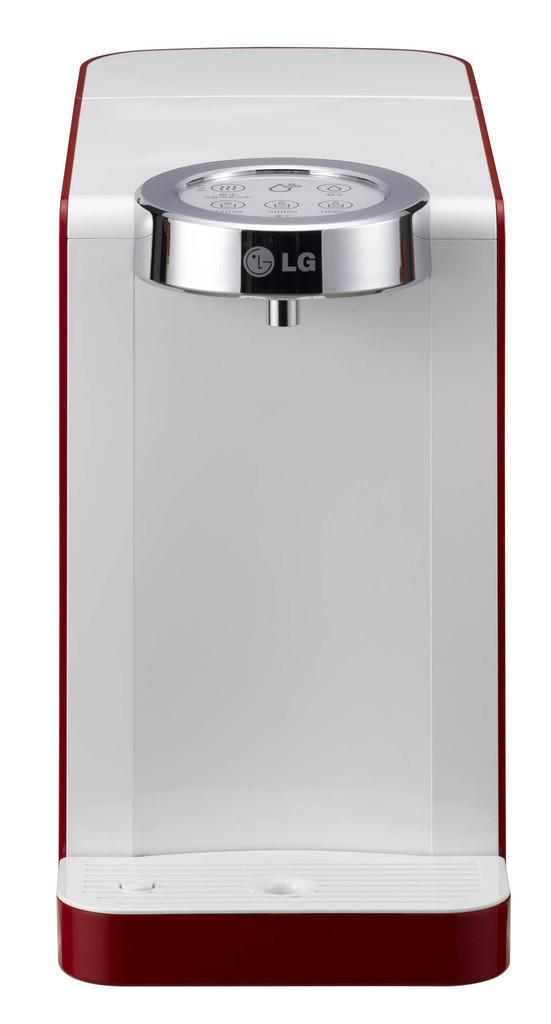Provide a one-sentence caption for the provided image. a white and red appliance with a silver piece that says LG on it is sitting in front of a white background. 